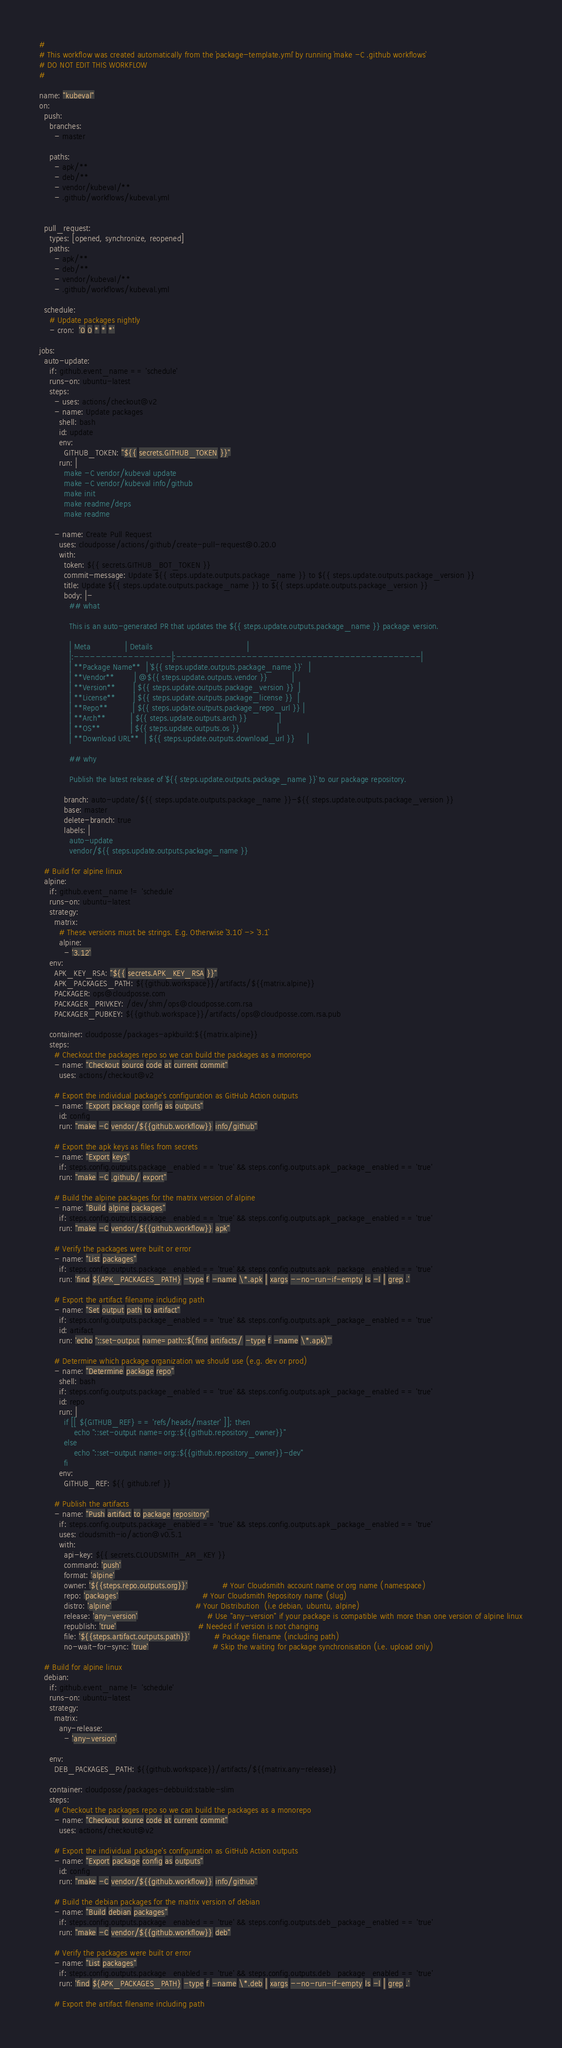Convert code to text. <code><loc_0><loc_0><loc_500><loc_500><_YAML_>#
# This workflow was created automatically from the `package-template.yml` by running `make -C .github workflows`
# DO NOT EDIT THIS WORKFLOW
#

name: "kubeval"
on:
  push:
    branches:
      - master

    paths:
      - apk/**
      - deb/**
      - vendor/kubeval/**
      - .github/workflows/kubeval.yml


  pull_request:
    types: [opened, synchronize, reopened]
    paths:
      - apk/**
      - deb/**
      - vendor/kubeval/**
      - .github/workflows/kubeval.yml

  schedule:
    # Update packages nightly
    - cron:  '0 0 * * *'

jobs:
  auto-update:
    if: github.event_name == 'schedule'
    runs-on: ubuntu-latest
    steps:
      - uses: actions/checkout@v2
      - name: Update packages
        shell: bash
        id: update
        env:
          GITHUB_TOKEN: "${{ secrets.GITHUB_TOKEN }}"
        run: |
          make -C vendor/kubeval update
          make -C vendor/kubeval info/github
          make init
          make readme/deps
          make readme

      - name: Create Pull Request
        uses: cloudposse/actions/github/create-pull-request@0.20.0
        with:
          token: ${{ secrets.GITHUB_BOT_TOKEN }}
          commit-message: Update ${{ steps.update.outputs.package_name }} to ${{ steps.update.outputs.package_version }}
          title: Update ${{ steps.update.outputs.package_name }} to ${{ steps.update.outputs.package_version }}
          body: |-
            ## what

            This is an auto-generated PR that updates the ${{ steps.update.outputs.package_name }} package version.
            
            | Meta              | Details                                      |
            |:------------------|:---------------------------------------------|
            | **Package Name**  | `${{ steps.update.outputs.package_name }}`   |
            | **Vendor**        | @${{ steps.update.outputs.vendor }}          |
            | **Version**       | ${{ steps.update.outputs.package_version }}  |
            | **License**       | ${{ steps.update.outputs.package_license }}  |
            | **Repo**          | ${{ steps.update.outputs.package_repo_url }} |
            | **Arch**          | ${{ steps.update.outputs.arch }}             |
            | **OS**            | ${{ steps.update.outputs.os }}               |
            | **Download URL**  | ${{ steps.update.outputs.download_url }}     |

            ## why

            Publish the latest release of `${{ steps.update.outputs.package_name }}` to our package repository.

          branch: auto-update/${{ steps.update.outputs.package_name }}-${{ steps.update.outputs.package_version }}
          base: master
          delete-branch: true
          labels: |
            auto-update
            vendor/${{ steps.update.outputs.package_name }}

  # Build for alpine linux
  alpine:
    if: github.event_name != 'schedule'
    runs-on: ubuntu-latest
    strategy:
      matrix:
        # These versions must be strings. E.g. Otherwise `3.10` -> `3.1`
        alpine:
          - '3.12'
    env:
      APK_KEY_RSA: "${{ secrets.APK_KEY_RSA }}"
      APK_PACKAGES_PATH: ${{github.workspace}}/artifacts/${{matrix.alpine}}
      PACKAGER: ops@cloudposse.com
      PACKAGER_PRIVKEY: /dev/shm/ops@cloudposse.com.rsa
      PACKAGER_PUBKEY: ${{github.workspace}}/artifacts/ops@cloudposse.com.rsa.pub

    container: cloudposse/packages-apkbuild:${{matrix.alpine}}
    steps:
      # Checkout the packages repo so we can build the packages as a monorepo
      - name: "Checkout source code at current commit"
        uses: actions/checkout@v2

      # Export the individual package's configuration as GitHub Action outputs
      - name: "Export package config as outputs"
        id: config
        run: "make -C vendor/${{github.workflow}} info/github"

      # Export the apk keys as files from secrets
      - name: "Export keys"
        if: steps.config.outputs.package_enabled == 'true' && steps.config.outputs.apk_package_enabled == 'true'
        run: "make -C .github/ export"

      # Build the alpine packages for the matrix version of alpine
      - name: "Build alpine packages"
        if: steps.config.outputs.package_enabled == 'true' && steps.config.outputs.apk_package_enabled == 'true'
        run: "make -C vendor/${{github.workflow}} apk"

      # Verify the packages were built or error
      - name: "List packages"
        if: steps.config.outputs.package_enabled == 'true' && steps.config.outputs.apk_package_enabled == 'true'
        run: 'find ${APK_PACKAGES_PATH} -type f -name \*.apk | xargs --no-run-if-empty ls -l | grep .'

      # Export the artifact filename including path
      - name: "Set output path to artifact"
        if: steps.config.outputs.package_enabled == 'true' && steps.config.outputs.apk_package_enabled == 'true'
        id: artifact
        run: 'echo "::set-output name=path::$(find artifacts/ -type f -name \*.apk)"'

      # Determine which package organization we should use (e.g. dev or prod)
      - name: "Determine package repo"
        shell: bash
        if: steps.config.outputs.package_enabled == 'true' && steps.config.outputs.apk_package_enabled == 'true'
        id: repo
        run: |
          if [[ ${GITHUB_REF} == 'refs/heads/master' ]]; then
              echo "::set-output name=org::${{github.repository_owner}}"
          else
              echo "::set-output name=org::${{github.repository_owner}}-dev"
          fi
        env:
          GITHUB_REF: ${{ github.ref }}

      # Publish the artifacts
      - name: "Push artifact to package repository"
        if: steps.config.outputs.package_enabled == 'true' && steps.config.outputs.apk_package_enabled == 'true'
        uses: cloudsmith-io/action@v0.5.1
        with:
          api-key: ${{ secrets.CLOUDSMITH_API_KEY }}
          command: 'push'
          format: 'alpine'
          owner: '${{steps.repo.outputs.org}}'              # Your Cloudsmith account name or org name (namespace)
          repo: 'packages'                                  # Your Cloudsmith Repository name (slug)
          distro: 'alpine'                                  # Your Distribution  (i.e debian, ubuntu, alpine)
          release: 'any-version'                            # Use "any-version" if your package is compatible with more than one version of alpine linux
          republish: 'true'                                 # Needed if version is not changing
          file: '${{steps.artifact.outputs.path}}'          # Package filename (including path)
          no-wait-for-sync: 'true'                          # Skip the waiting for package synchronisation (i.e. upload only)

  # Build for alpine linux
  debian:
    if: github.event_name != 'schedule'
    runs-on: ubuntu-latest
    strategy:
      matrix:
        any-release:
          - 'any-version'

    env:
      DEB_PACKAGES_PATH: ${{github.workspace}}/artifacts/${{matrix.any-release}}

    container: cloudposse/packages-debbuild:stable-slim
    steps:
      # Checkout the packages repo so we can build the packages as a monorepo
      - name: "Checkout source code at current commit"
        uses: actions/checkout@v2

      # Export the individual package's configuration as GitHub Action outputs
      - name: "Export package config as outputs"
        id: config
        run: "make -C vendor/${{github.workflow}} info/github"

      # Build the debian packages for the matrix version of debian
      - name: "Build debian packages"
        if: steps.config.outputs.package_enabled == 'true' && steps.config.outputs.deb_package_enabled == 'true'
        run: "make -C vendor/${{github.workflow}} deb"

      # Verify the packages were built or error
      - name: "List packages"
        if: steps.config.outputs.package_enabled == 'true' && steps.config.outputs.deb_package_enabled == 'true'
        run: 'find ${APK_PACKAGES_PATH} -type f -name \*.deb | xargs --no-run-if-empty ls -l | grep .'

      # Export the artifact filename including path</code> 